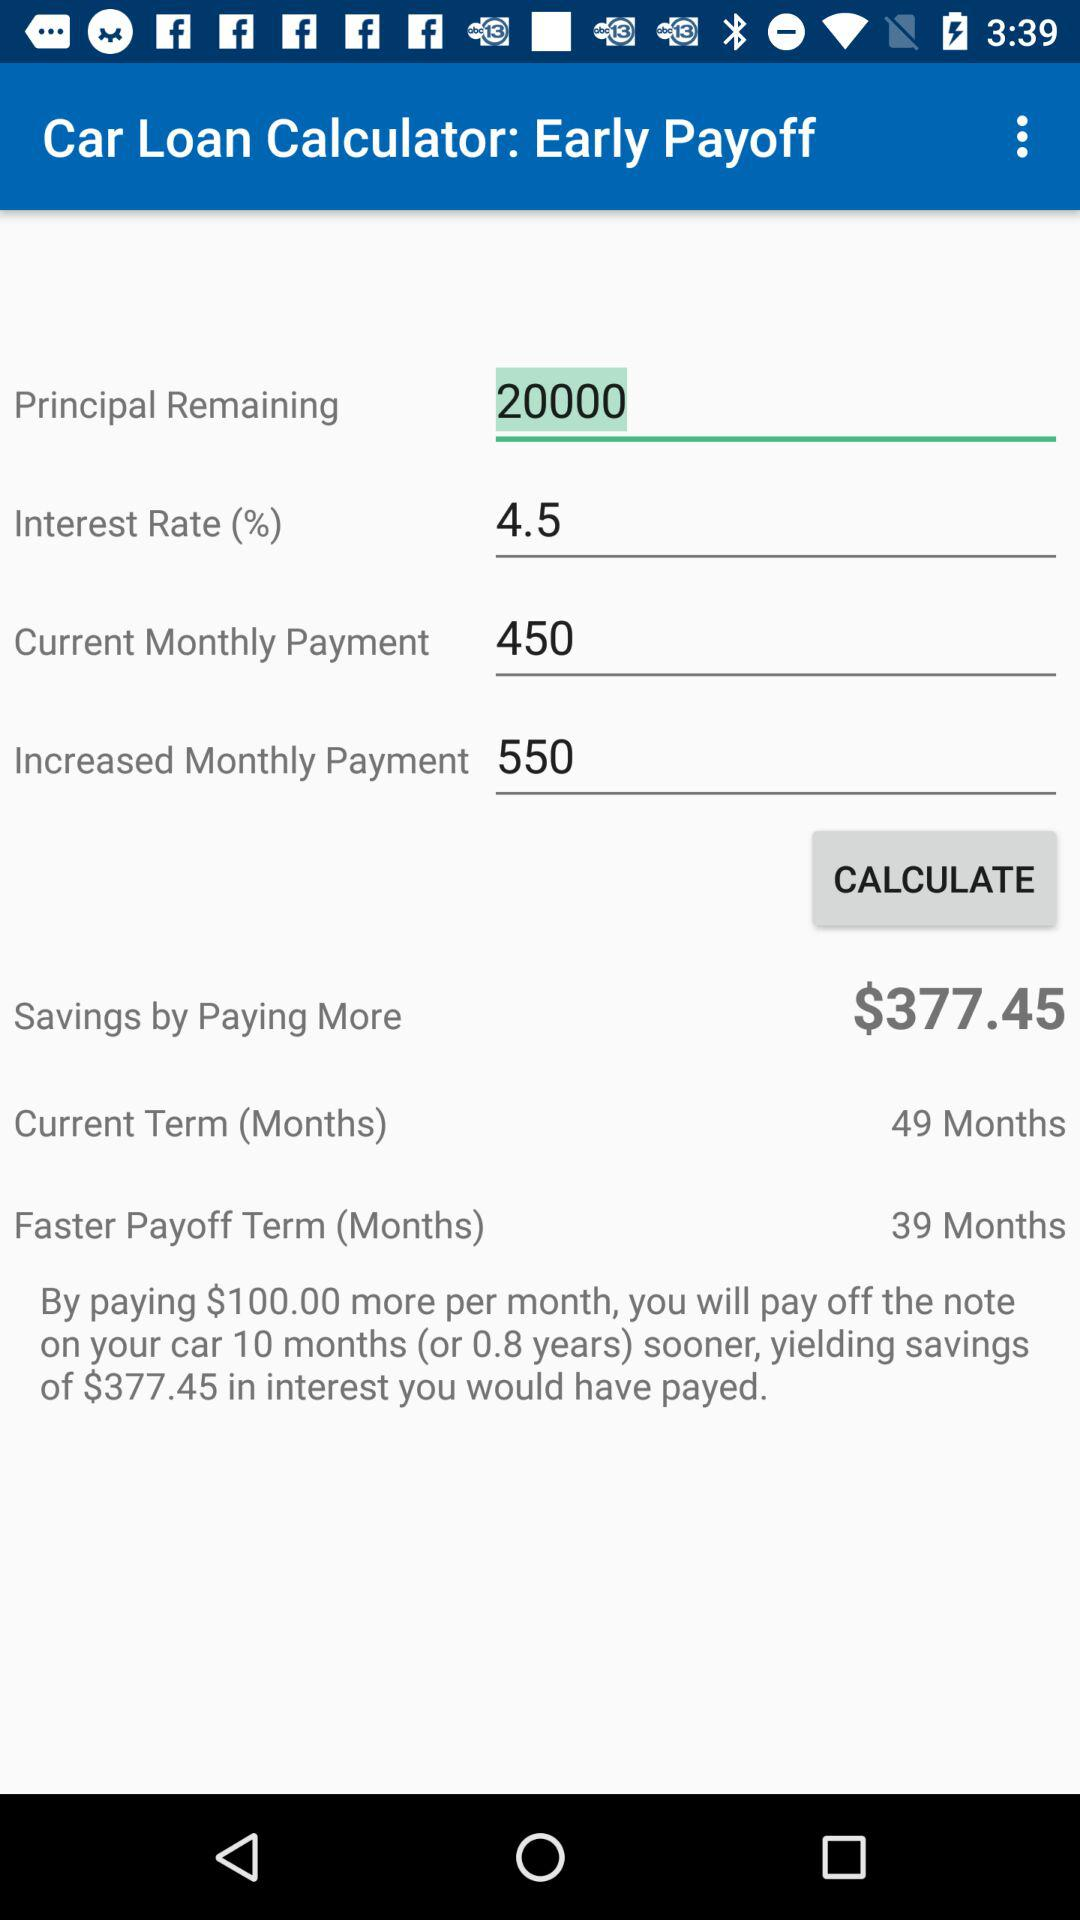What is the principal remaining? The principal remaining is 20000. 